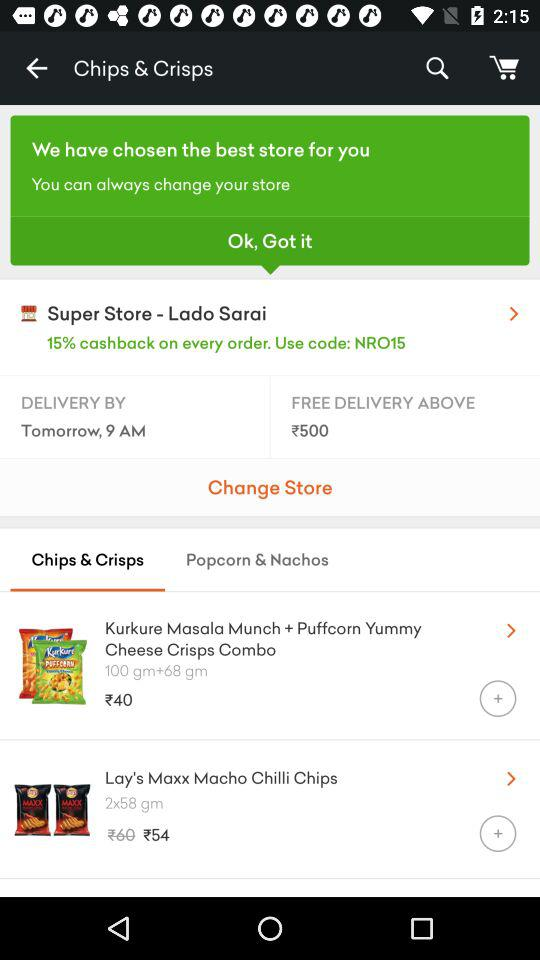What is the discounted price of 2 packets of "Lay's Maxx Macho Chilli Chips"? The discounted price of 2 packets of "Lay's Maxx Macho Chilli Chips" is ₹54. 